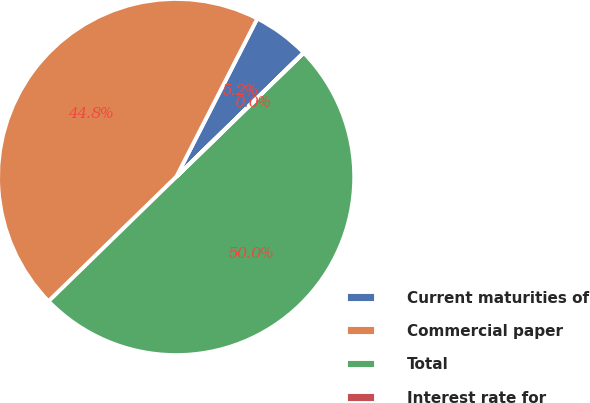Convert chart to OTSL. <chart><loc_0><loc_0><loc_500><loc_500><pie_chart><fcel>Current maturities of<fcel>Commercial paper<fcel>Total<fcel>Interest rate for<nl><fcel>5.17%<fcel>44.83%<fcel>50.0%<fcel>0.01%<nl></chart> 